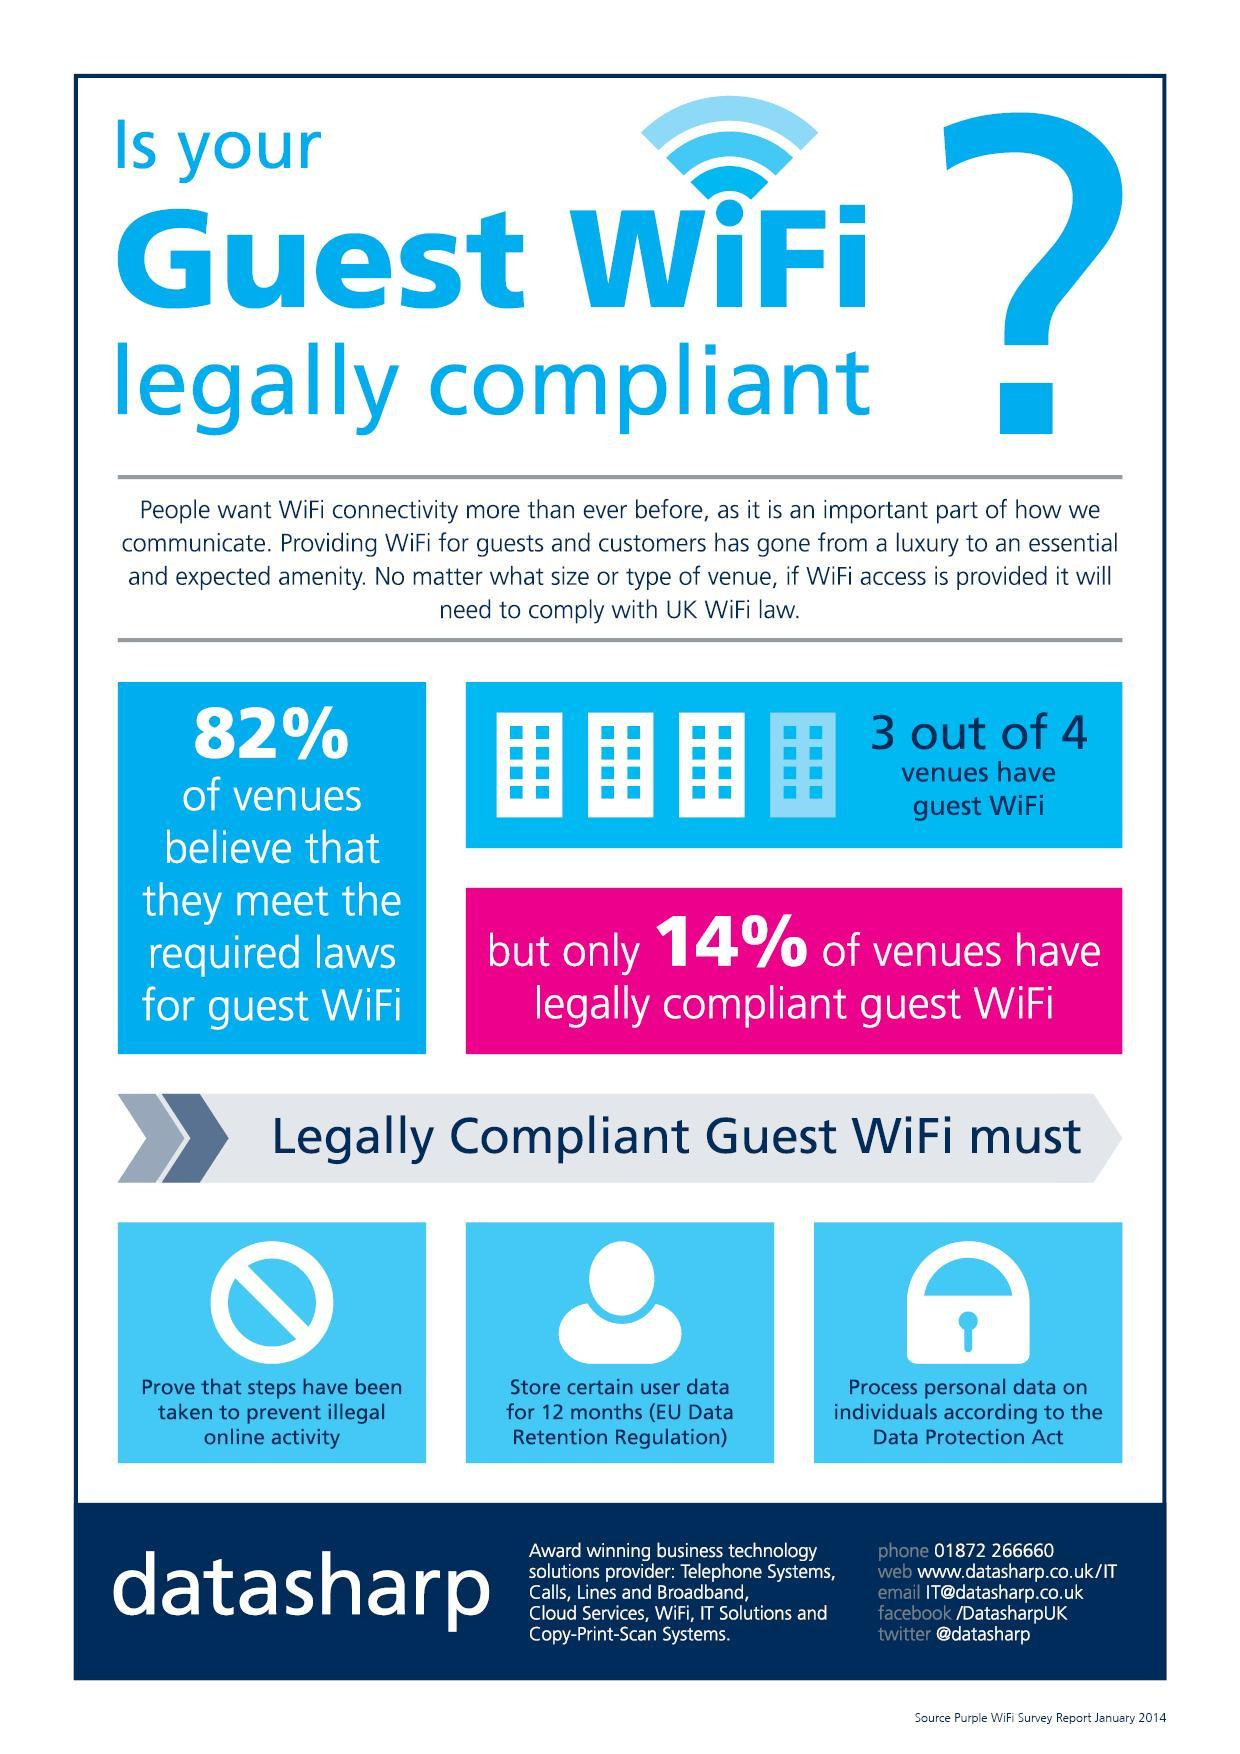What is the number of icons of lock in this infographic?
Answer the question with a short phrase. 1 What is the percentage of Wi-Fi guest venues that comply with the UK Wi-Fi law? 14 What is the third criteria for guest Wi-Fi to be considered as legally compliant? process personal data on individuals according to the data protection act What is the percentage of venues that doesn't have guest Wi-Fi? 25 What is the color of the question mark symbol - blue, white or black? blue What is the color of the lock icon - blue, white or black? white How many times the word 82 appeared in this infographics? 1 What is the second criteria for guest Wi-Fi to be considered as legally compliant? store certain user data for 12 month What is the percentage of venues that have guest Wi-Fi? 75 What is the color of the text "14%" - blue, white or black? white 